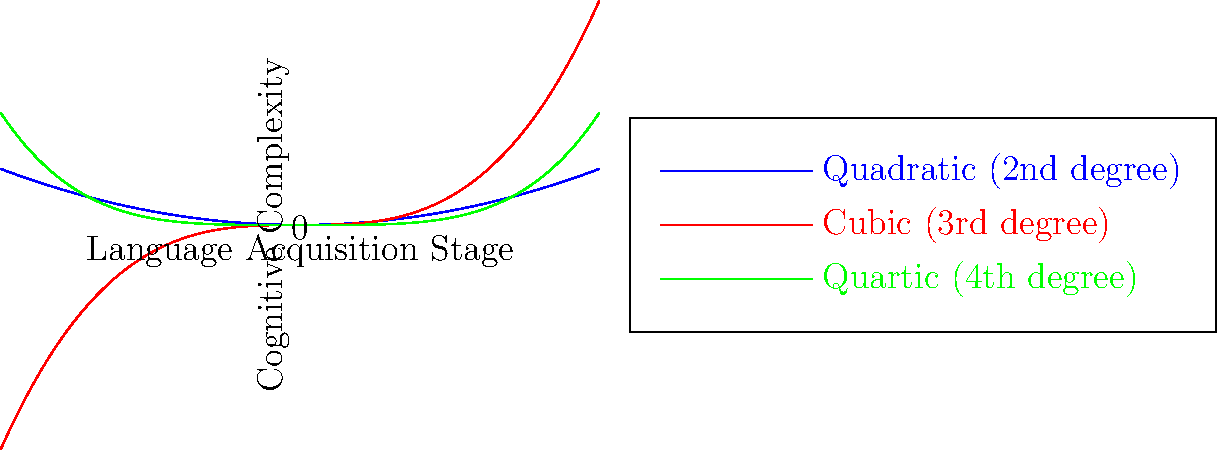Based on the polynomial graph representation of language acquisition stages and cognitive complexity, which degree polynomial most accurately reflects the rapid increase in cognitive complexity during the early stages of language acquisition, followed by a more gradual increase in later stages? To answer this question, we need to analyze the behavior of each polynomial curve in relation to language acquisition stages and cognitive complexity:

1. Quadratic (2nd degree, blue curve):
   - Starts with a gentle increase
   - Accelerates more rapidly as language acquisition progresses
   - Does not show a clear distinction between early and later stages

2. Cubic (3rd degree, red curve):
   - Begins with a steeper increase in the early stages
   - Shows a more gradual increase in the middle stages
   - Accelerates again in the later stages
   - Does not match the described pattern of rapid early increase followed by gradual later increase

3. Quartic (4th degree, green curve):
   - Demonstrates a rapid increase in cognitive complexity during early language acquisition stages
   - The rate of increase slows down in the middle and later stages
   - Maintains a gradual increase in complexity during later stages
   - Best matches the described pattern of language acquisition

The quartic (4th degree) polynomial most accurately represents the rapid increase in cognitive complexity during early language acquisition stages, followed by a more gradual increase in later stages. This aligns with psycholinguistic theories that suggest a critical period for language acquisition, where cognitive development related to language is most rapid in the early years and then continues at a slower pace.
Answer: Quartic (4th degree) polynomial 